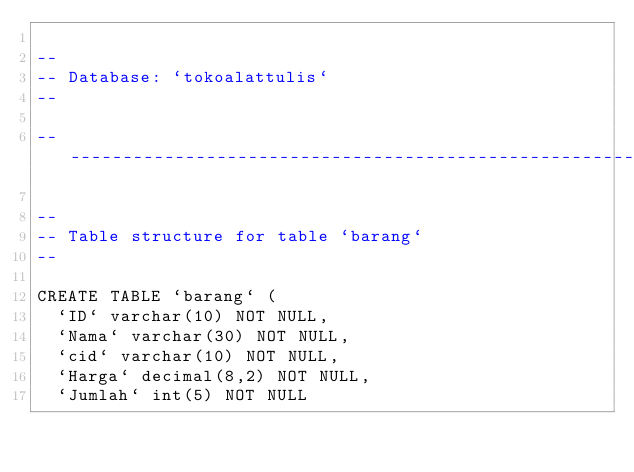<code> <loc_0><loc_0><loc_500><loc_500><_SQL_>
--
-- Database: `tokoalattulis`
--

-- --------------------------------------------------------

--
-- Table structure for table `barang`
--

CREATE TABLE `barang` (
  `ID` varchar(10) NOT NULL,
  `Nama` varchar(30) NOT NULL,
  `cid` varchar(10) NOT NULL,
  `Harga` decimal(8,2) NOT NULL,
  `Jumlah` int(5) NOT NULL</code> 